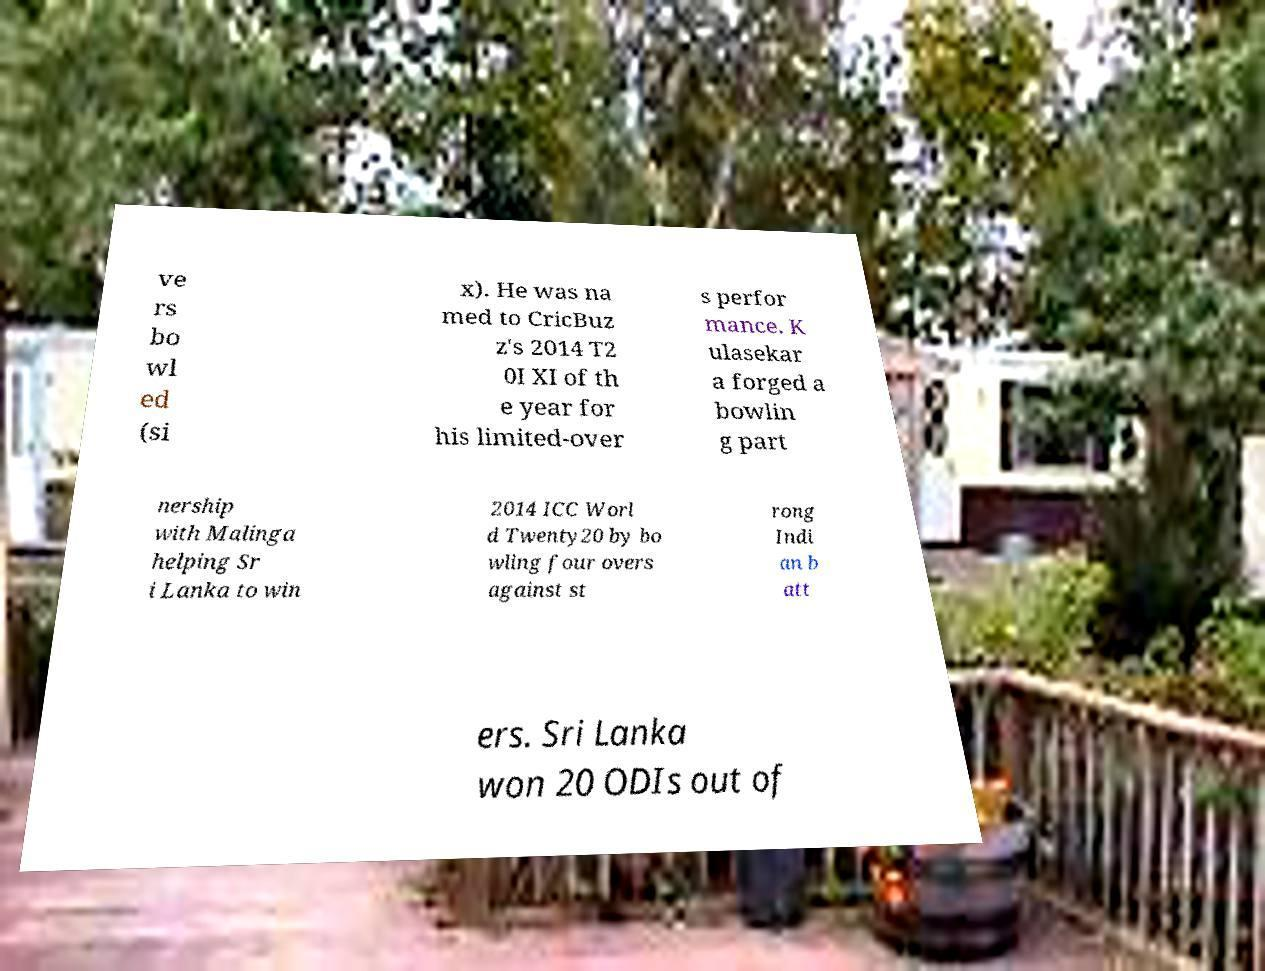Could you assist in decoding the text presented in this image and type it out clearly? ve rs bo wl ed (si x). He was na med to CricBuz z's 2014 T2 0I XI of th e year for his limited-over s perfor mance. K ulasekar a forged a bowlin g part nership with Malinga helping Sr i Lanka to win 2014 ICC Worl d Twenty20 by bo wling four overs against st rong Indi an b att ers. Sri Lanka won 20 ODIs out of 